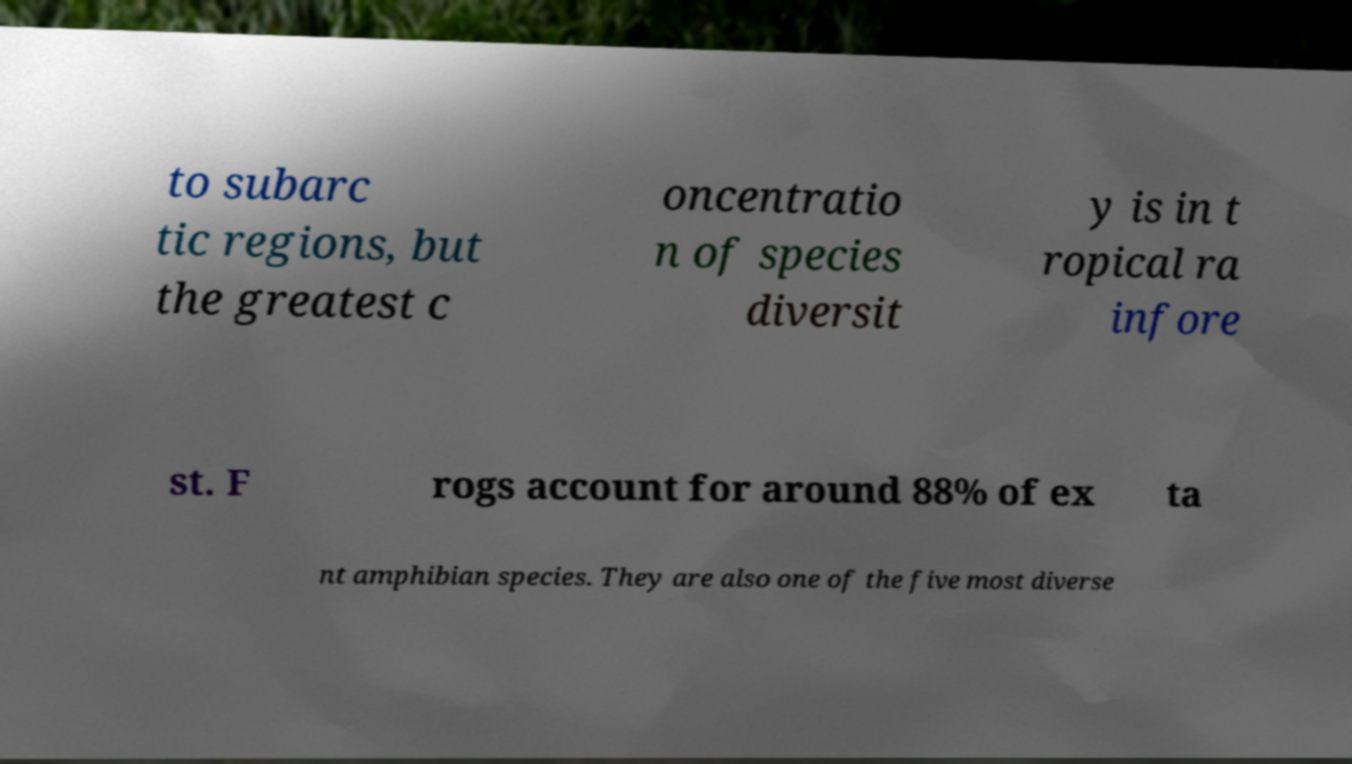Please identify and transcribe the text found in this image. to subarc tic regions, but the greatest c oncentratio n of species diversit y is in t ropical ra infore st. F rogs account for around 88% of ex ta nt amphibian species. They are also one of the five most diverse 